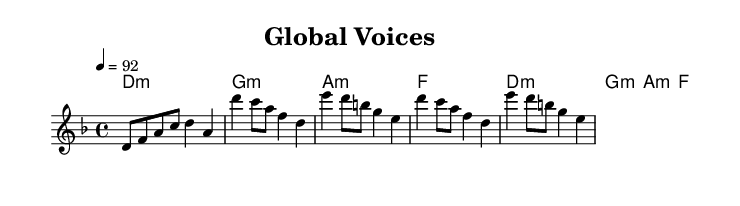What is the key signature of this music? The key signature is D minor, which has one flat (B flat). This can be identified by looking at the key signature indicated at the beginning of the sheet music.
Answer: D minor What is the time signature of this music? The time signature is 4/4, which means there are four beats in a measure and the quarter note receives one beat. This can be determined by the notation shown at the beginning of the score.
Answer: 4/4 What is the tempo marking in this piece? The tempo marking is 92, which indicates the beats per minute (BPM) that the piece should be played at. This is indicated in the tempo instruction at the beginning of the score.
Answer: 92 How many measures are in the melody section? There are eight measures in the melody section, which is calculated by counting the segments divided by the vertical bar lines in the melody staff.
Answer: 8 What type of chords are used throughout the piece? The piece uses minor chords, as indicated by the "m" notation in the chord names section. This is a characteristic of mood and emotion often found in rap music.
Answer: Minor What is repeated in the chorus section? The chorus section repeats the melodic line and rhythmic pattern multiple times, specifically the sequence of notes and rhythms from the initial melodic statement. This repetition is common in rap to emphasize the message.
Answer: The chorus How does the harmony progress in this piece? The harmony progresses through a sequence of minor and major chords: D minor, G minor, A minor, and F major, providing an emotional backdrop that complements the melody and theme, typical in rap collaborations.
Answer: D minor, G minor, A minor, F major 